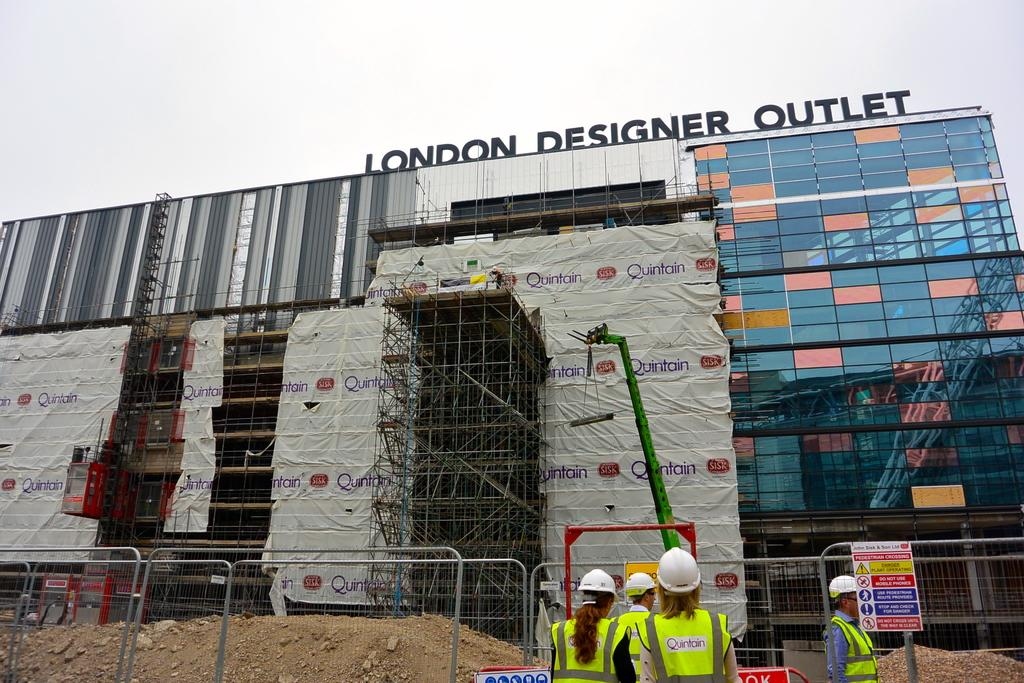What is the main subject of the image? The main subject of the image is a building. What is the current state of the building? The building is under construction. Are there any people visible in the image? Yes, there are people standing at the railing of the building. What is the condition of the sky in the image? The sky is clear in the image. What type of cake is being served at the construction site in the image? There is no cake present in the image; it features a building under construction with people standing at the railing. 